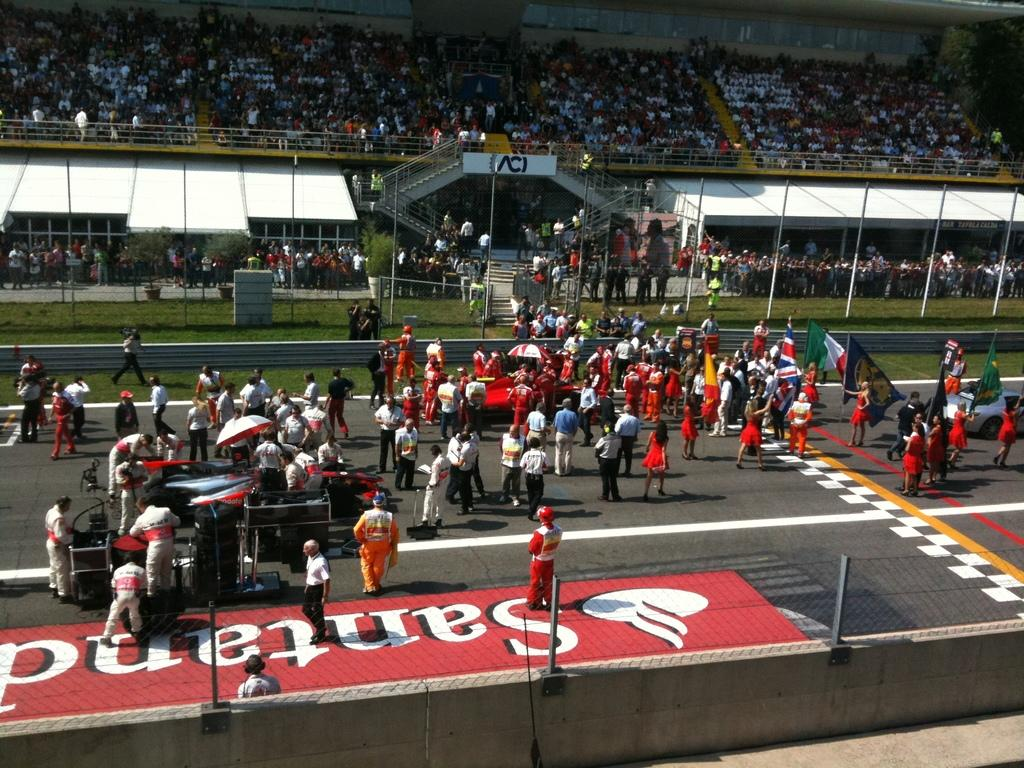Provide a one-sentence caption for the provided image. A Santand logo is on the ground near a bunch of people wearing red. 